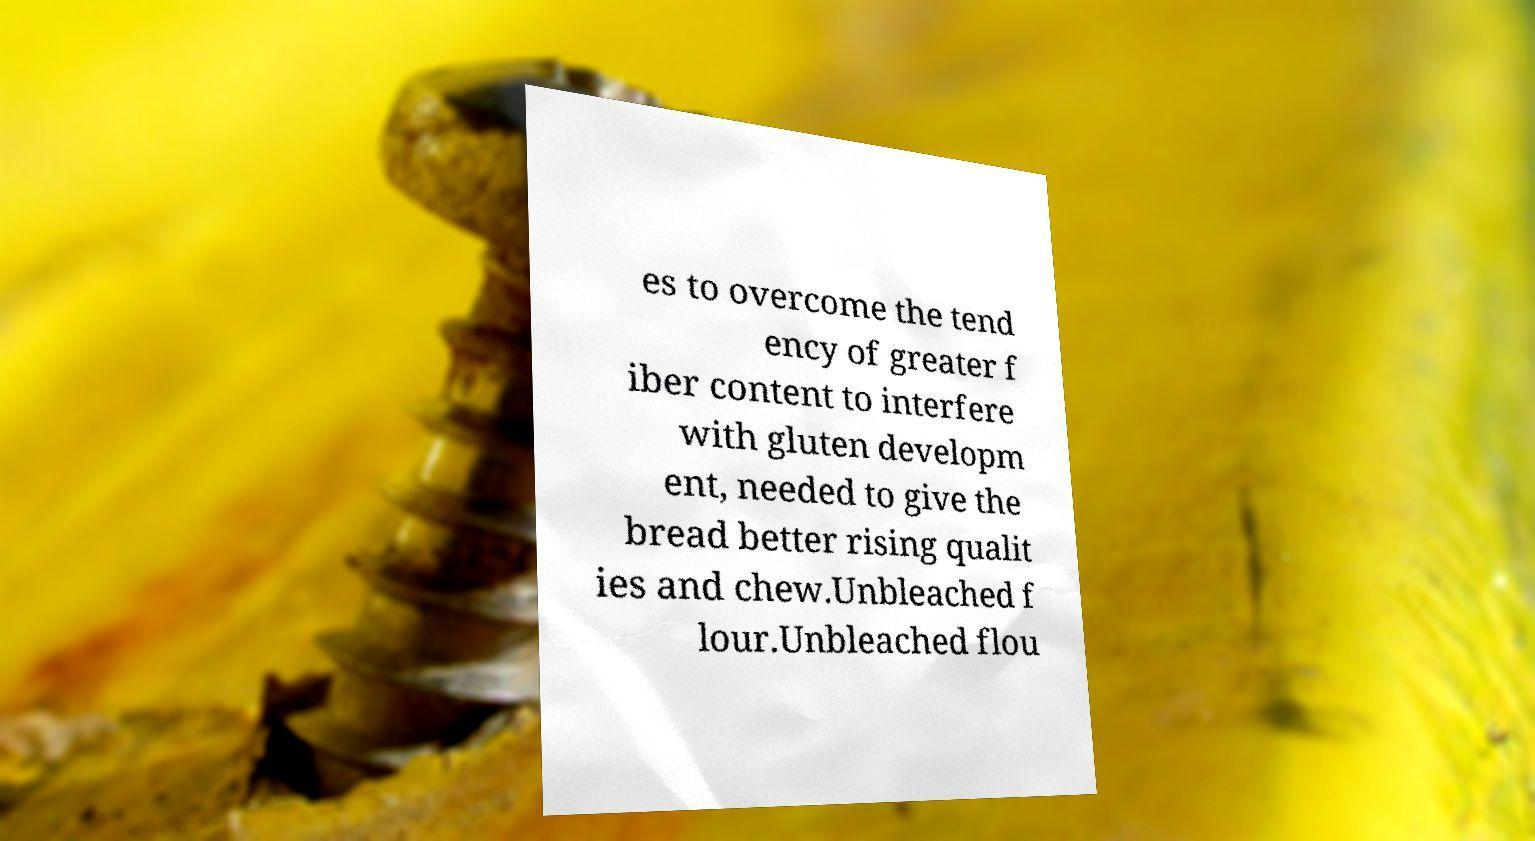Could you extract and type out the text from this image? es to overcome the tend ency of greater f iber content to interfere with gluten developm ent, needed to give the bread better rising qualit ies and chew.Unbleached f lour.Unbleached flou 